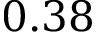<formula> <loc_0><loc_0><loc_500><loc_500>0 . 3 8</formula> 